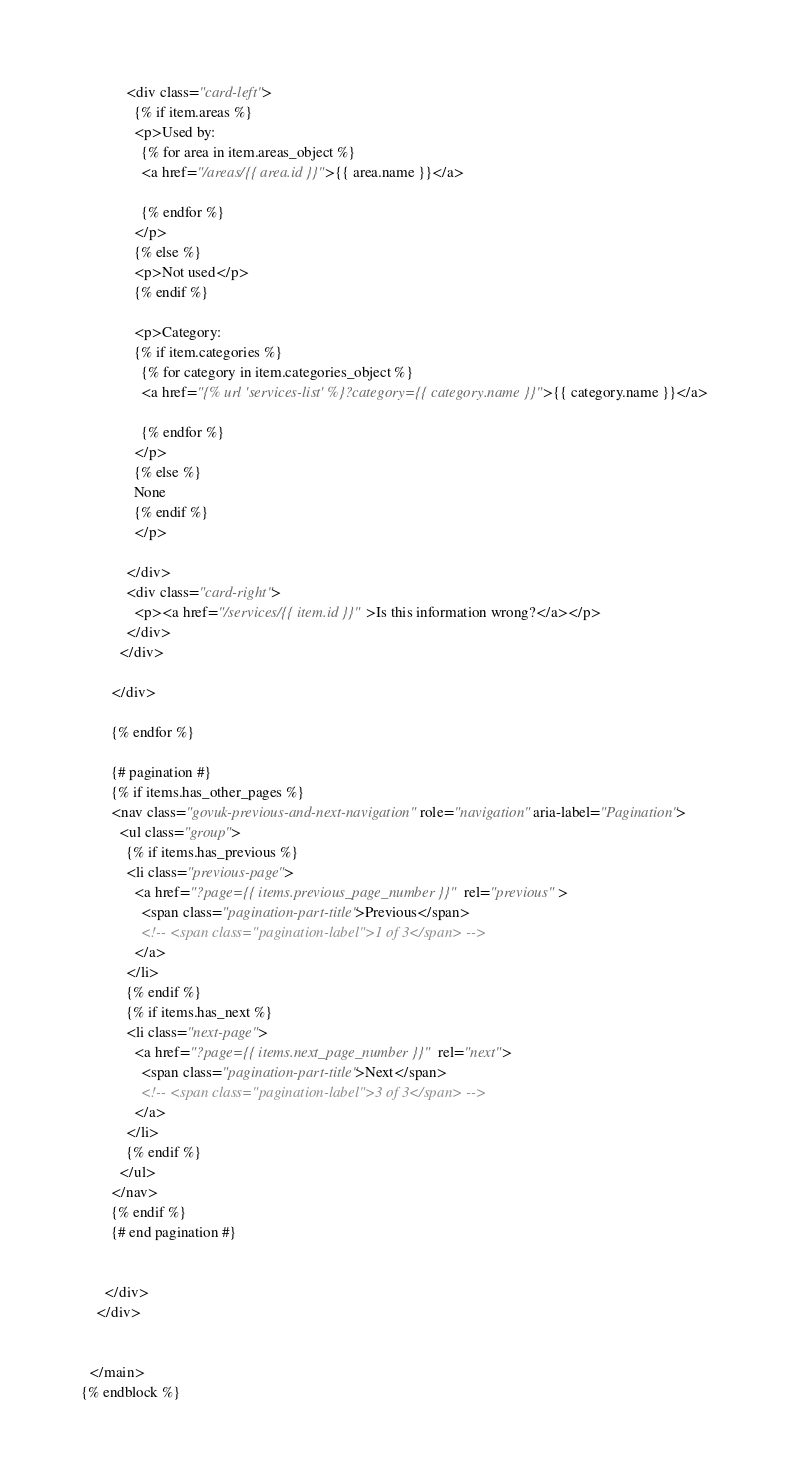Convert code to text. <code><loc_0><loc_0><loc_500><loc_500><_HTML_>            <div class="card-left">
              {% if item.areas %}
              <p>Used by:
                {% for area in item.areas_object %}
                <a href="/areas/{{ area.id }}">{{ area.name }}</a>

                {% endfor %}
              </p>
              {% else %}
              <p>Not used</p>
              {% endif %}

              <p>Category:
              {% if item.categories %}
                {% for category in item.categories_object %}
                <a href="{% url 'services-list' %}?category={{ category.name }}">{{ category.name }}</a>

                {% endfor %}
              </p>
              {% else %}
              None
              {% endif %}
              </p>

            </div>
            <div class="card-right">
              <p><a href="/services/{{ item.id }}">Is this information wrong?</a></p>
            </div>
          </div>

        </div>

        {% endfor %}

        {# pagination #}
        {% if items.has_other_pages %}
        <nav class="govuk-previous-and-next-navigation" role="navigation" aria-label="Pagination">
          <ul class="group">
            {% if items.has_previous %}
            <li class="previous-page">
              <a href="?page={{ items.previous_page_number }}" rel="previous" >
                <span class="pagination-part-title">Previous</span>
                <!-- <span class="pagination-label">1 of 3</span> -->
              </a>
            </li>
            {% endif %}
            {% if items.has_next %}
            <li class="next-page">
              <a href="?page={{ items.next_page_number }}" rel="next">
                <span class="pagination-part-title">Next</span>
                <!-- <span class="pagination-label">3 of 3</span> -->
              </a>
            </li>
            {% endif %}
          </ul>
        </nav>
        {% endif %}
        {# end pagination #}


      </div>
    </div>


  </main>
{% endblock %}
</code> 